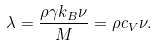<formula> <loc_0><loc_0><loc_500><loc_500>\lambda = \frac { \rho \gamma k _ { B } \nu } { M } = \rho c _ { V } \nu .</formula> 